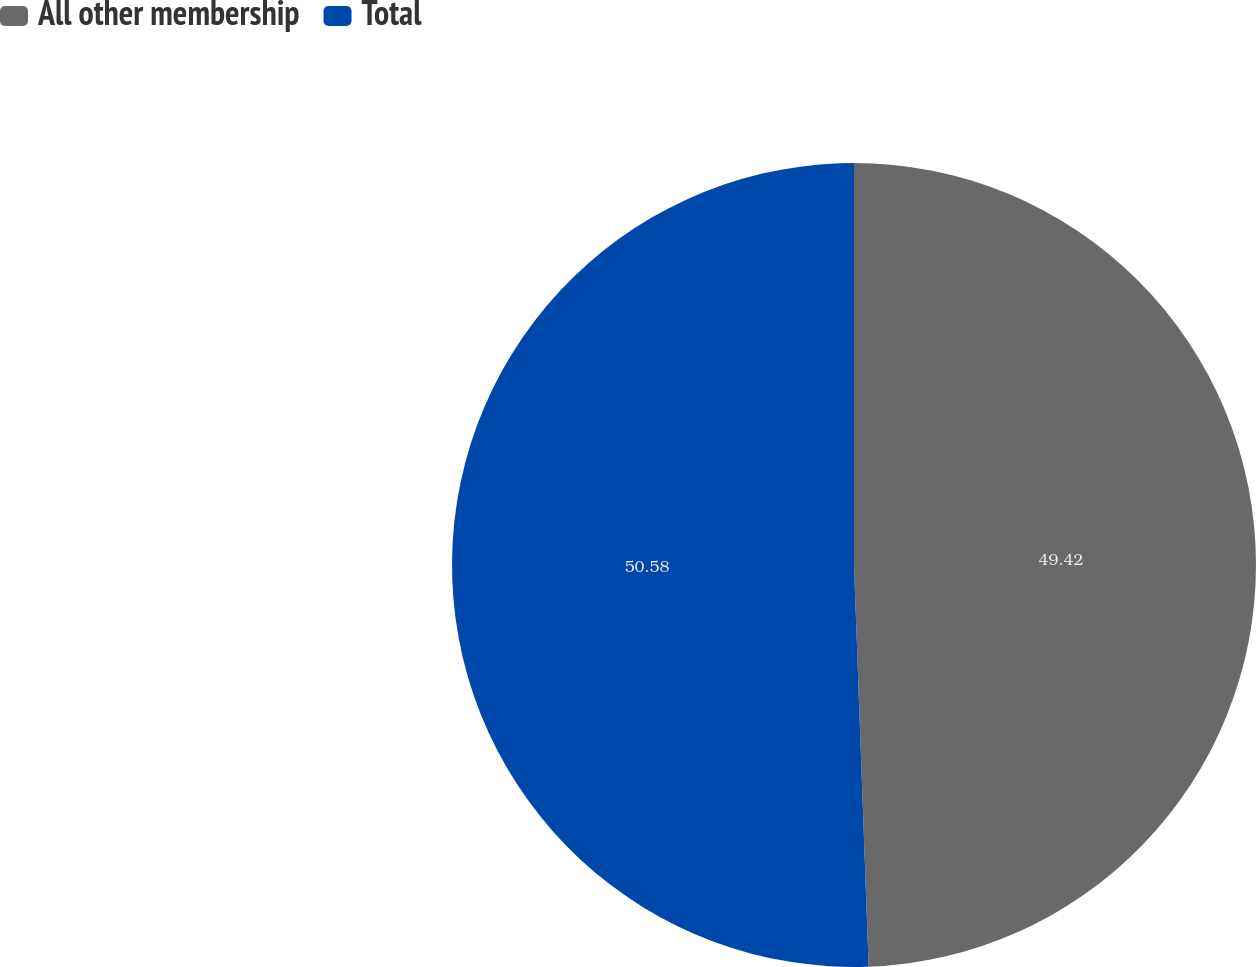Convert chart. <chart><loc_0><loc_0><loc_500><loc_500><pie_chart><fcel>All other membership<fcel>Total<nl><fcel>49.42%<fcel>50.58%<nl></chart> 